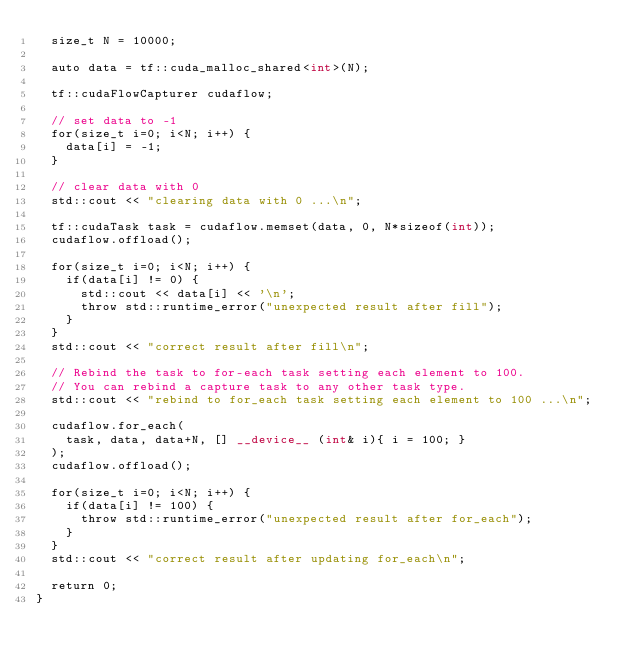<code> <loc_0><loc_0><loc_500><loc_500><_Cuda_>  size_t N = 10000;

  auto data = tf::cuda_malloc_shared<int>(N);
  
  tf::cudaFlowCapturer cudaflow;

  // set data to -1
  for(size_t i=0; i<N; i++) {
    data[i] = -1;
  }
  
  // clear data with 0
  std::cout << "clearing data with 0 ...\n";

  tf::cudaTask task = cudaflow.memset(data, 0, N*sizeof(int));
  cudaflow.offload();

  for(size_t i=0; i<N; i++) {
    if(data[i] != 0) {
      std::cout << data[i] << '\n';
      throw std::runtime_error("unexpected result after fill");
    }
  }
  std::cout << "correct result after fill\n";

  // Rebind the task to for-each task setting each element to 100.
  // You can rebind a capture task to any other task type.
  std::cout << "rebind to for_each task setting each element to 100 ...\n";

  cudaflow.for_each(
    task, data, data+N, [] __device__ (int& i){ i = 100; }
  );
  cudaflow.offload();
  
  for(size_t i=0; i<N; i++) {
    if(data[i] != 100) {
      throw std::runtime_error("unexpected result after for_each");
    }
  }
  std::cout << "correct result after updating for_each\n";

  return 0;
}



</code> 